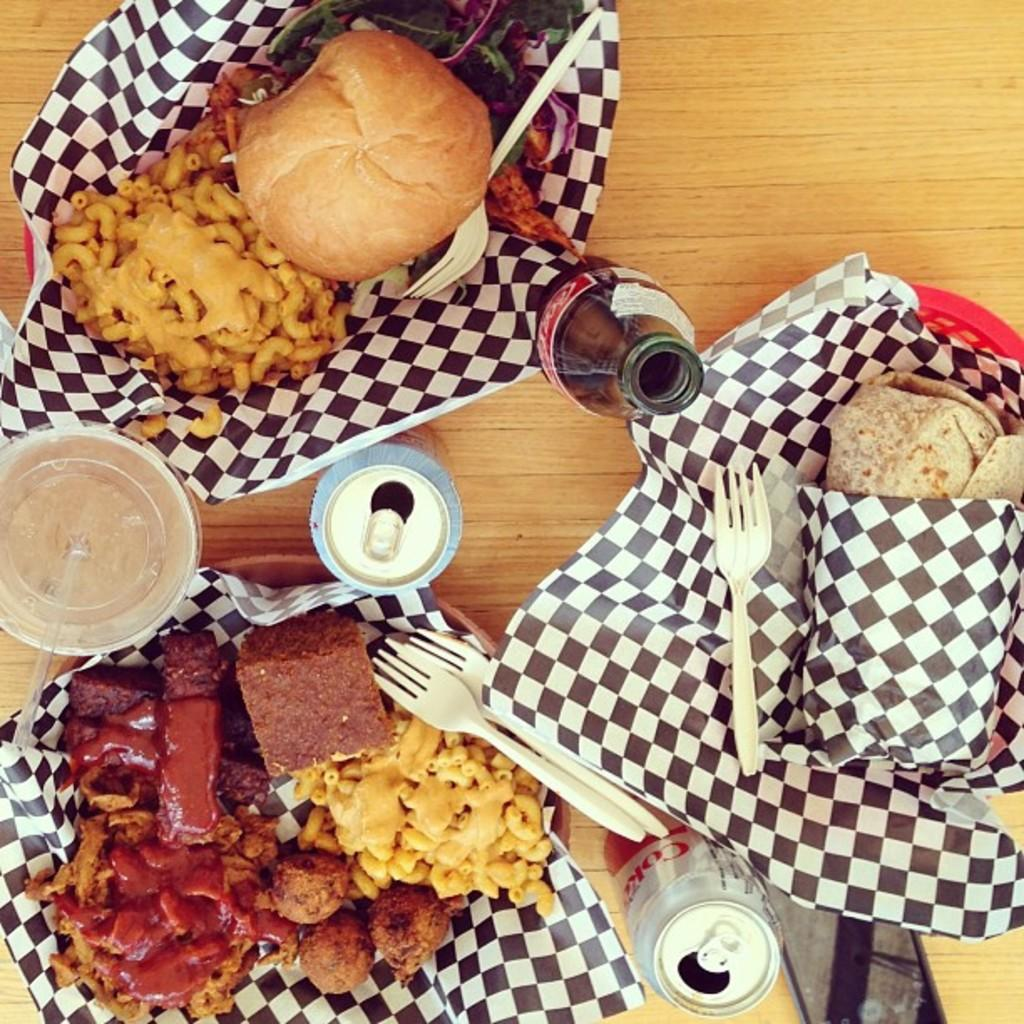What type of items can be seen on the table in the image? There are food items on the table in the image. Can you identify any specific beverage on the table? Yes, there is a coke bottle on the table. What utensils are present on the table? There are forks present on the table. What type of quartz can be seen on the table in the image? There is no quartz present on the table in the image. Is anyone driving a vehicle in the image? There is no indication of a vehicle or driving in the image. 